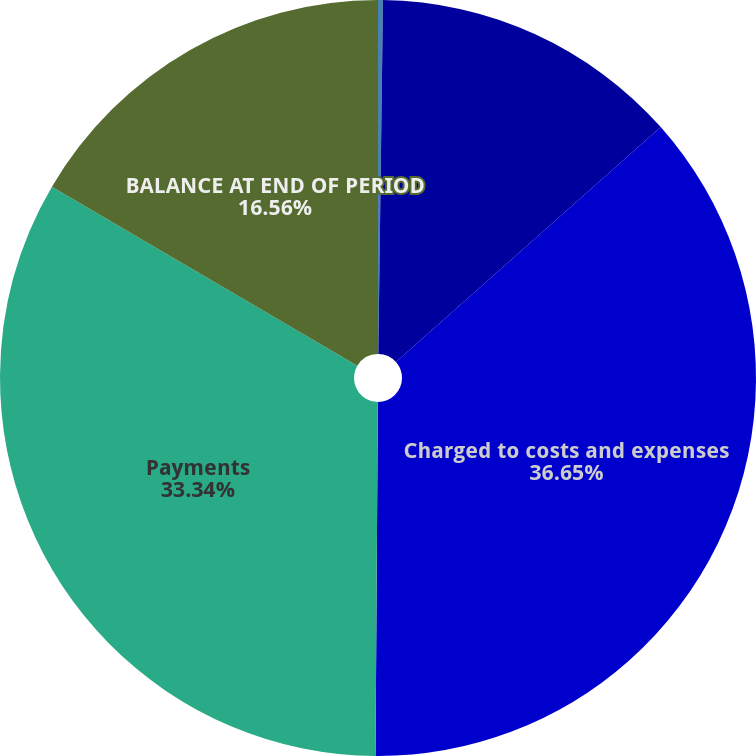Convert chart. <chart><loc_0><loc_0><loc_500><loc_500><pie_chart><fcel>(In thousands)<fcel>Balance at beginning of period<fcel>Charged to costs and expenses<fcel>Payments<fcel>BALANCE AT END OF PERIOD<nl><fcel>0.21%<fcel>13.24%<fcel>36.66%<fcel>33.34%<fcel>16.56%<nl></chart> 